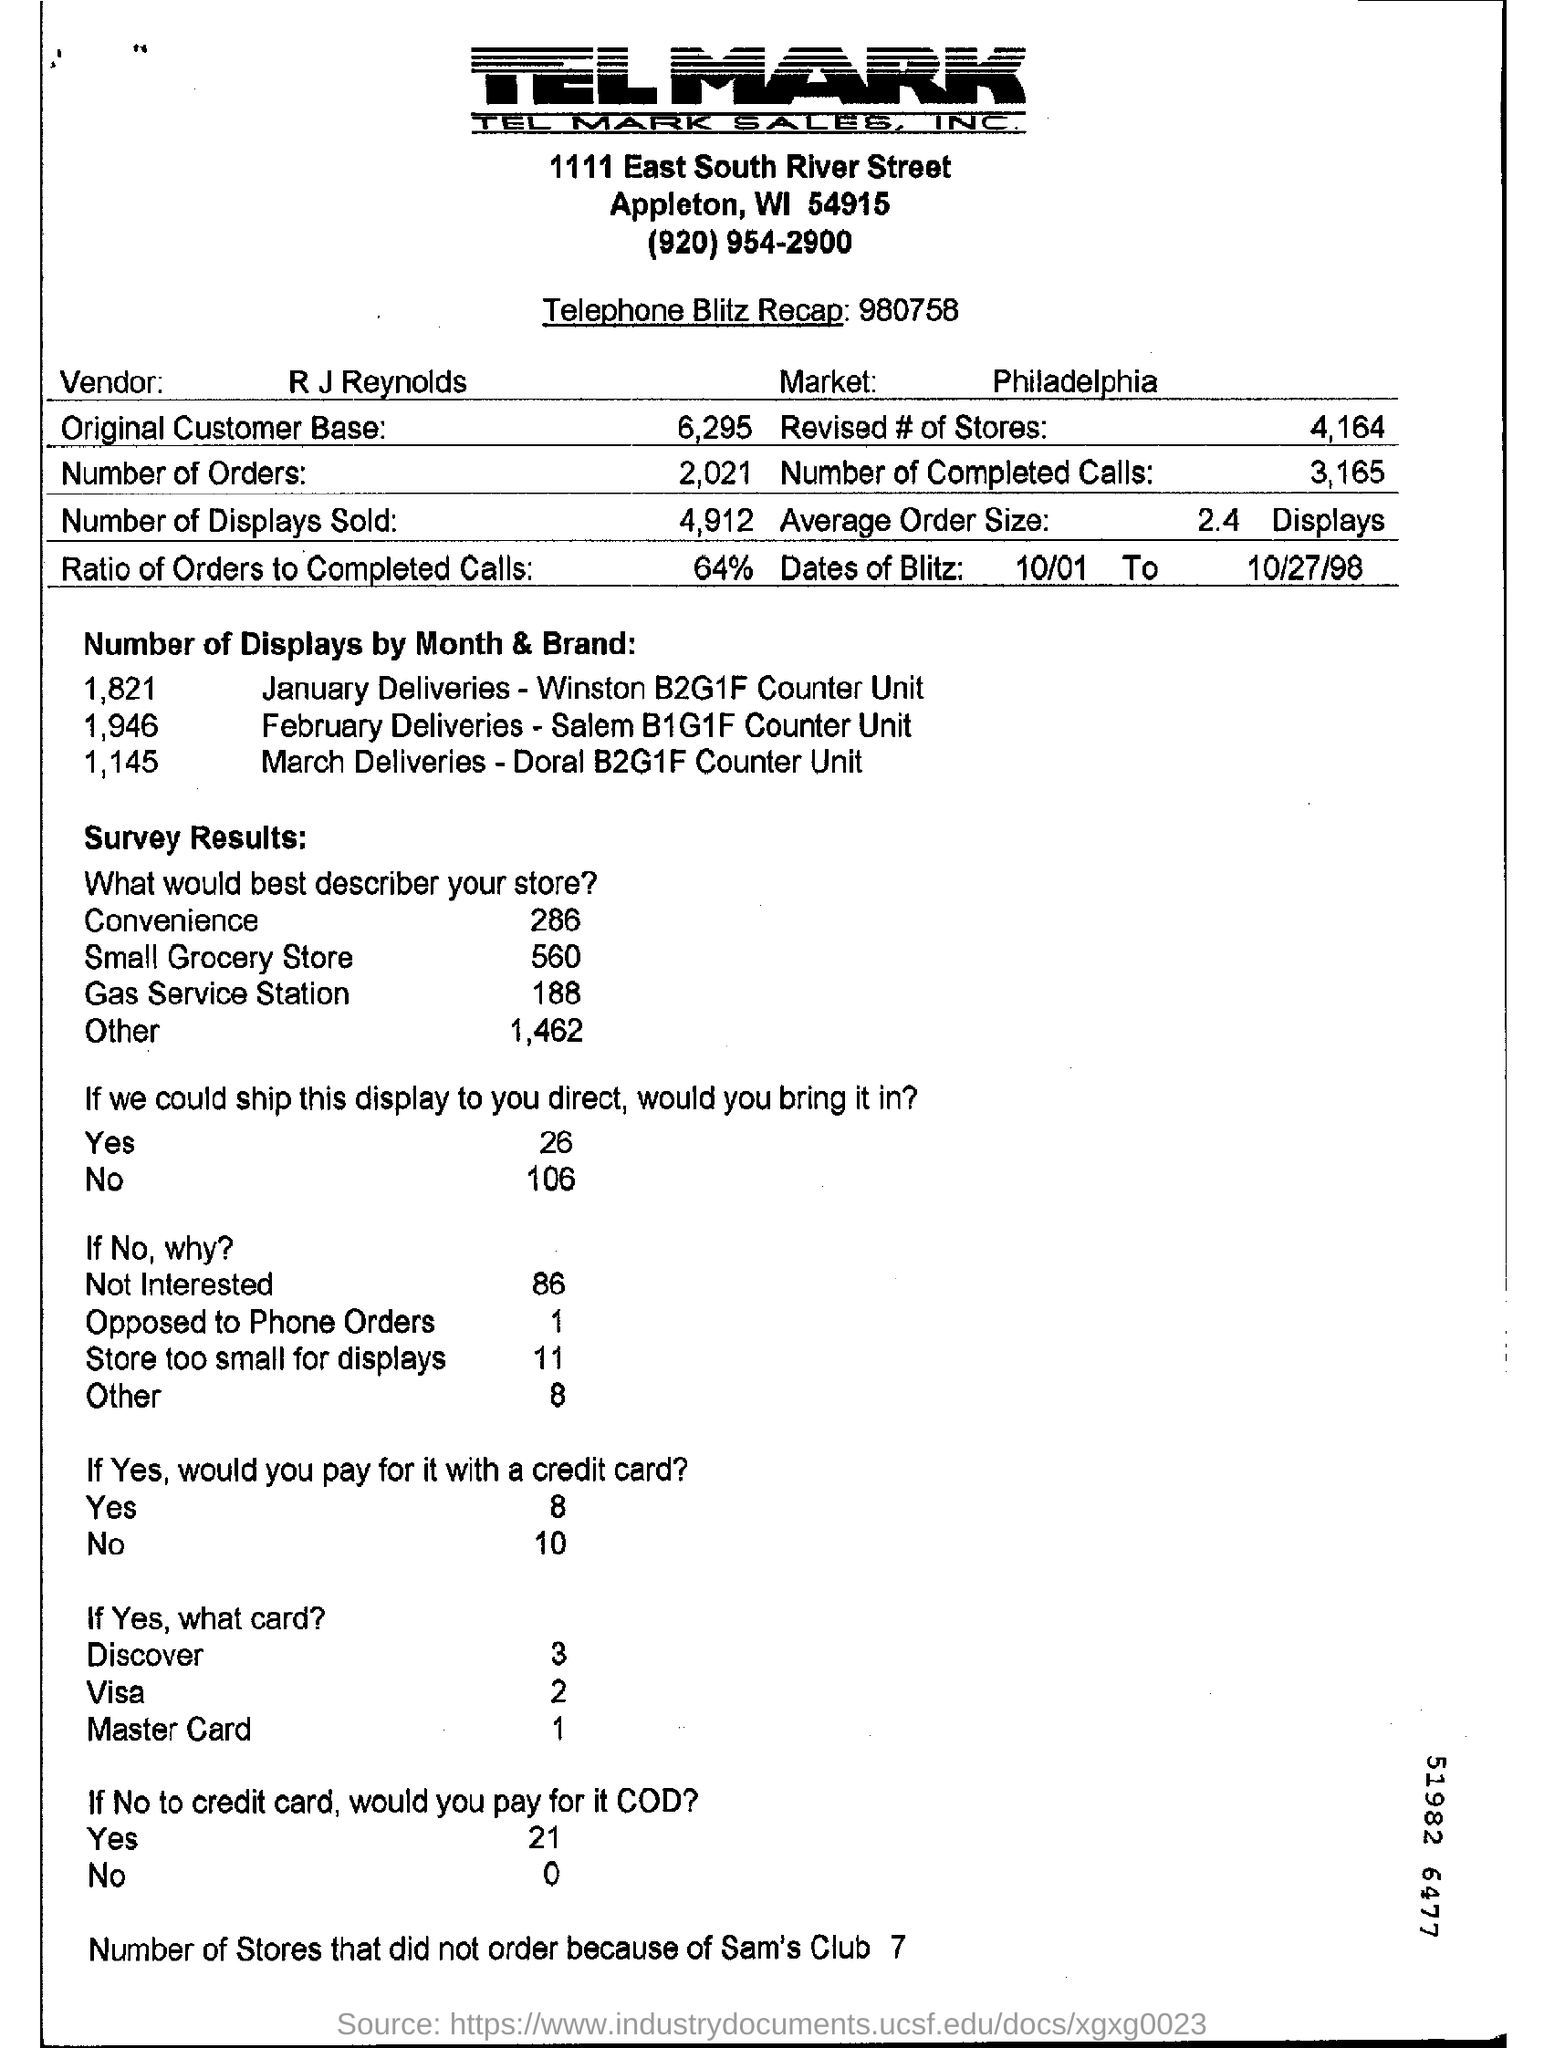Indicate a few pertinent items in this graphic. The ratio of orders to completed calls is 64%. The average order size is 2.4, which is displayed. The vendor's name is R.J. Reynolds. The revised store count mentioned in the form is 4,164. There are a total of 3,165 completed calls mentioned in the form. 